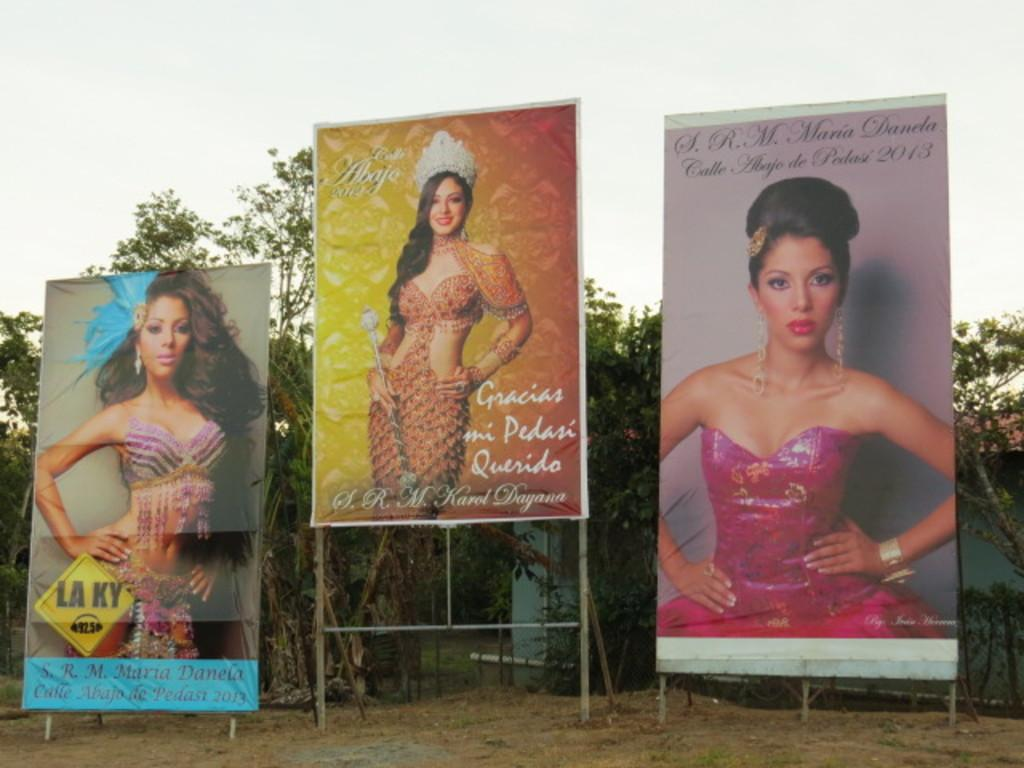What type of vegetation can be seen in the image? There are trees in the image. What type of structure is visible in the image? There is a wall in the image. What are the banners on poles used for in the image? The banners on poles are used for displaying information or advertising in the image. What is visible at the top of the image? The sky is visible at the top of the image. What is visible at the bottom of the image? The ground is visible at the bottom of the image. What flavor of ice cream is being advertised on the banners in the image? There is no ice cream or flavor mentioned in the image; the banners are on poles but their content is not specified. What is the texture of the wall in the image? The texture of the wall cannot be determined from the image alone, as it only provides a visual representation of the wall. 